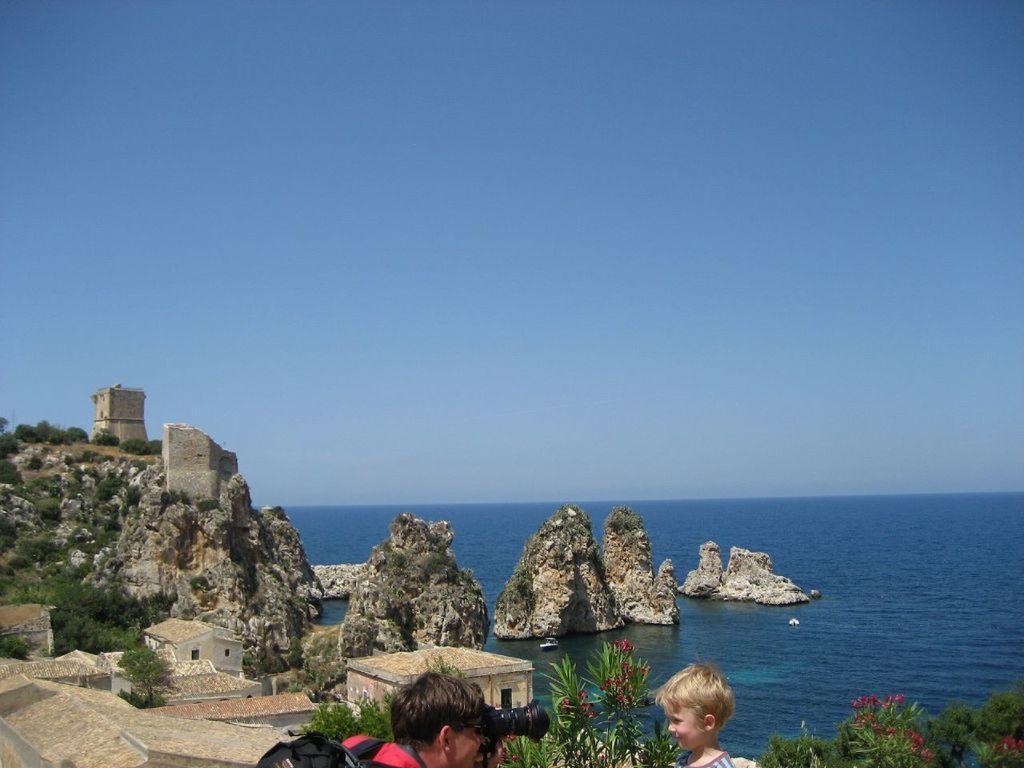Please provide a concise description of this image. In this picture I can see there is a boy at right side, there is a man holding a camera and there are few plants at right side, there are a few buildings and an ocean at the right side. The sky is clear. 